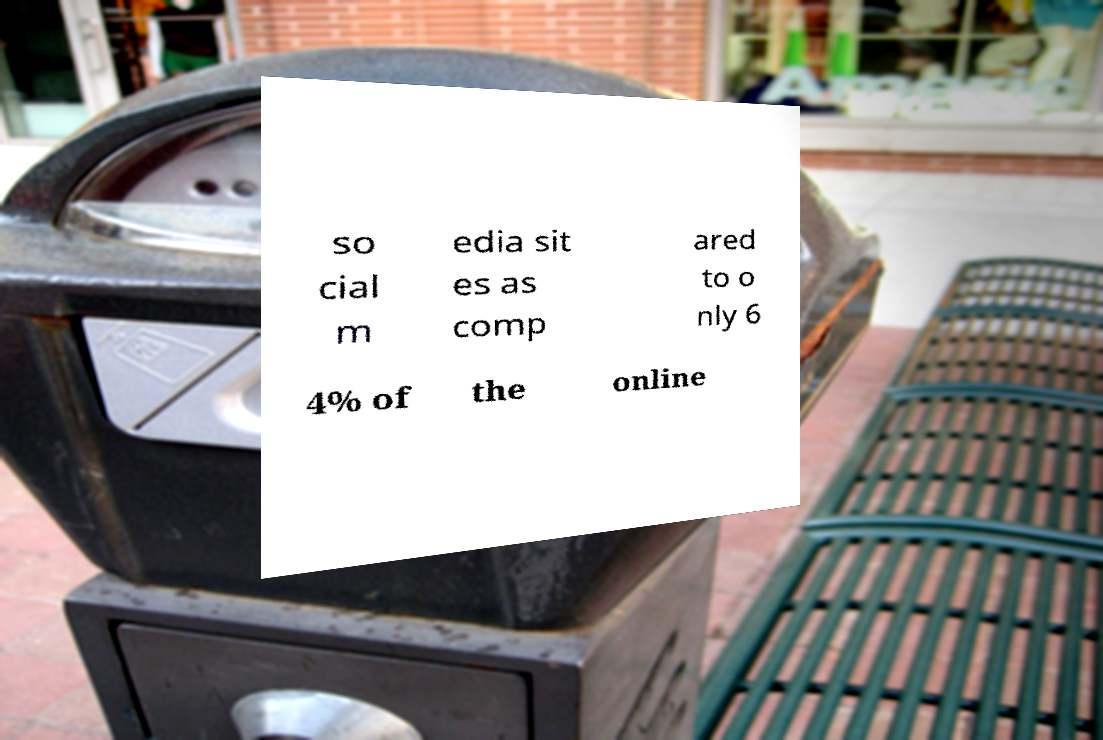I need the written content from this picture converted into text. Can you do that? so cial m edia sit es as comp ared to o nly 6 4% of the online 